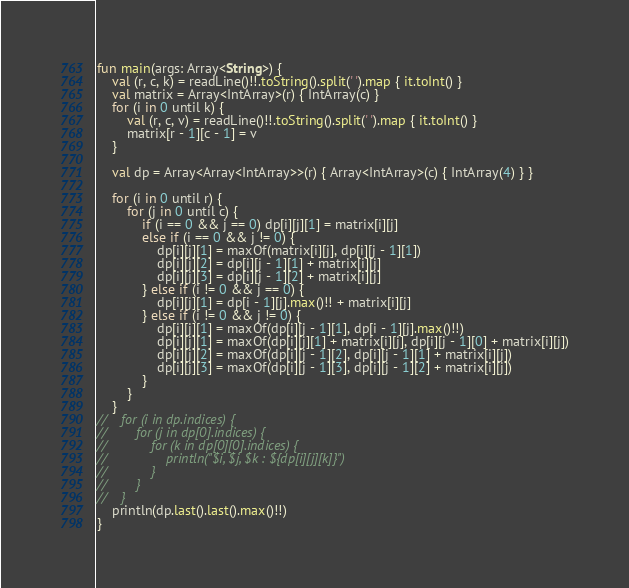Convert code to text. <code><loc_0><loc_0><loc_500><loc_500><_Kotlin_>fun main(args: Array<String>) {
    val (r, c, k) = readLine()!!.toString().split(' ').map { it.toInt() }
    val matrix = Array<IntArray>(r) { IntArray(c) }
    for (i in 0 until k) {
        val (r, c, v) = readLine()!!.toString().split(' ').map { it.toInt() }
        matrix[r - 1][c - 1] = v
    }

    val dp = Array<Array<IntArray>>(r) { Array<IntArray>(c) { IntArray(4) } }

    for (i in 0 until r) {
        for (j in 0 until c) {
            if (i == 0 && j == 0) dp[i][j][1] = matrix[i][j]
            else if (i == 0 && j != 0) {
                dp[i][j][1] = maxOf(matrix[i][j], dp[i][j - 1][1])
                dp[i][j][2] = dp[i][j - 1][1] + matrix[i][j]
                dp[i][j][3] = dp[i][j - 1][2] + matrix[i][j]
            } else if (i != 0 && j == 0) {
                dp[i][j][1] = dp[i - 1][j].max()!! + matrix[i][j]
            } else if (i != 0 && j != 0) {
                dp[i][j][1] = maxOf(dp[i][j - 1][1], dp[i - 1][j].max()!!)
                dp[i][j][1] = maxOf(dp[i][j][1] + matrix[i][j], dp[i][j - 1][0] + matrix[i][j])
                dp[i][j][2] = maxOf(dp[i][j - 1][2], dp[i][j - 1][1] + matrix[i][j])
                dp[i][j][3] = maxOf(dp[i][j - 1][3], dp[i][j - 1][2] + matrix[i][j])
            }
        }
    }
//    for (i in dp.indices) {
//        for (j in dp[0].indices) {
//            for (k in dp[0][0].indices) {
//                println("$i, $j, $k : ${dp[i][j][k]}")
//            }
//        }
//    }
    println(dp.last().last().max()!!)
}</code> 